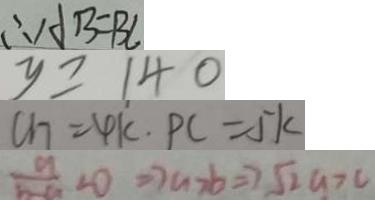Convert formula to latex. <formula><loc_0><loc_0><loc_500><loc_500>\therefore A B = B C 
 y \geq 1 4 0 
 C H = 4 k . P C = 5 k 
 \frac { a } { b - a } < 0 \Rightarrow a > b \Rightarrow \sqrt { 2 } a > c</formula> 